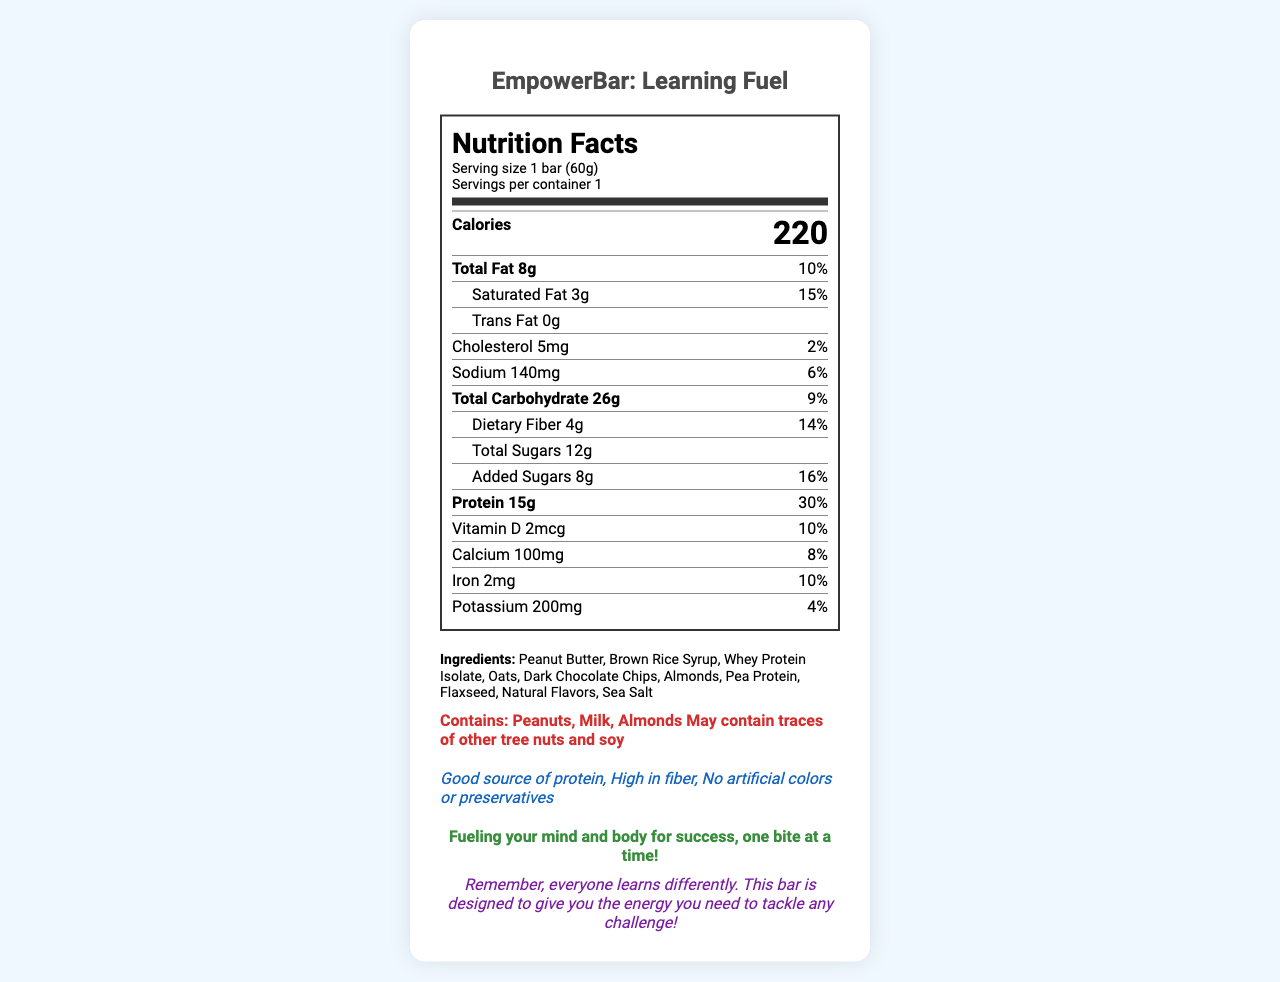what is the serving size for EmpowerBar: Learning Fuel? The serving size is listed at the top of the document as "Serving size 1 bar (60g)".
Answer: 1 bar (60g) how many calories does one bar contain? The number of calories is prominently displayed in bold within the first few lines of the document under the "Calories" section.
Answer: 220 what percentage of the daily value of protein does one bar provide? Under the "Protein" section, it's noted that 15g of protein makes up 30% of the daily value.
Answer: 30% is there any trans fat in the EmpowerBar: Learning Fuel? The document states "Trans Fat 0g" under the "Total Fat" section.
Answer: No which vitamin or mineral has a daily value of 4% in this bar? In the nutrient breakdown, it is shown that potassium has a daily value of 4%.
Answer: Potassium which ingredient is listed first? The ingredients list starts with "Peanut Butter", indicating it is the primary ingredient.
Answer: Peanut Butter how much total fat is in the bar? The document states "Total Fat 8g" under the "Total Fat" section.
Answer: 8g what is the daily value percentage for saturated fat? The document lists "Saturated Fat 3g" with a daily value of 15% under the "Total Fat" breakdown.
Answer: 15% how much dietary fiber is in one serving of the bar? The "Dietary Fiber" section mentions 4g per serving.
Answer: 4g which of the following is not an allergen listed? A. Peanuts B. Milk C. Soy D. Wheat The listed allergens are "Contains: Peanuts, Milk, Almonds, May contain traces of other tree nuts and soy". Wheat is not mentioned.
Answer: D how many grams of added sugars are in one bar? Under the "Total Sugars" section, the document specifies "Added Sugars 8g".
Answer: 8g true or false: The bar contains artificial colors or preservatives. Under "special features", the document notes "No artificial colors or preservatives".
Answer: False what does the empathy message say? The empathy message is located towards the end of the document in green and bold.
Answer: Fueling your mind and body for success, one bite at a time! summarize the content of the Nutrition Facts Label for EmpowerBar: Learning Fuel. This summary encapsulates the main nutritional information, ingredients, allergens, and special features, as well as the motivational message included in the document.
Answer: The EmpowerBar: Learning Fuel has 220 calories per bar with 8g of total fat, 26g of carbohydrates, and 15g of protein. It provides various nutrients such as vitamins and minerals with specified daily values. The ingredients include peanut butter, brown rice syrup, whey protein isolate, and more. The bar contains peanuts, milk, and almonds as allergens and possibly tree nuts and soy. Special features highlight it as a high-protein, high-fiber bar without artificial colors or preservatives. Additionally, enclosed is a motivational message to support learners. based on the document, will this bar provide enough calcium equal to 100% of daily value? The Calcium content in the bar is listed as "100mg" which is 8% of the daily value, far below 100%.
Answer: No how many special features are mentioned for the bar? The document lists three special features: "Good source of protein", "High in fiber", and "No artificial colors or preservatives".
Answer: Three what is the main purpose of the encouragement note included in the document? The encouragement note provides reassurance and motivation, emphasizing that everyone learns differently and this bar is designed to give the necessary energy to face challenges.
Answer: To motivate and support individuals in their learning journey how many ingredients are used in the EmpowerBar: Learning Fuel? The ingredients section lists ten items: Peanut Butter, Brown Rice Syrup, Whey Protein Isolate, Oats, Dark Chocolate Chips, Almonds, Pea Protein, Flaxseed, Natural Flavors, and Sea Salt.
Answer: Ten what type of oil is used in the EmpowerBar: Learning Fuel? The document does not provide details on the type of oil used in the product.
Answer: Not enough information 